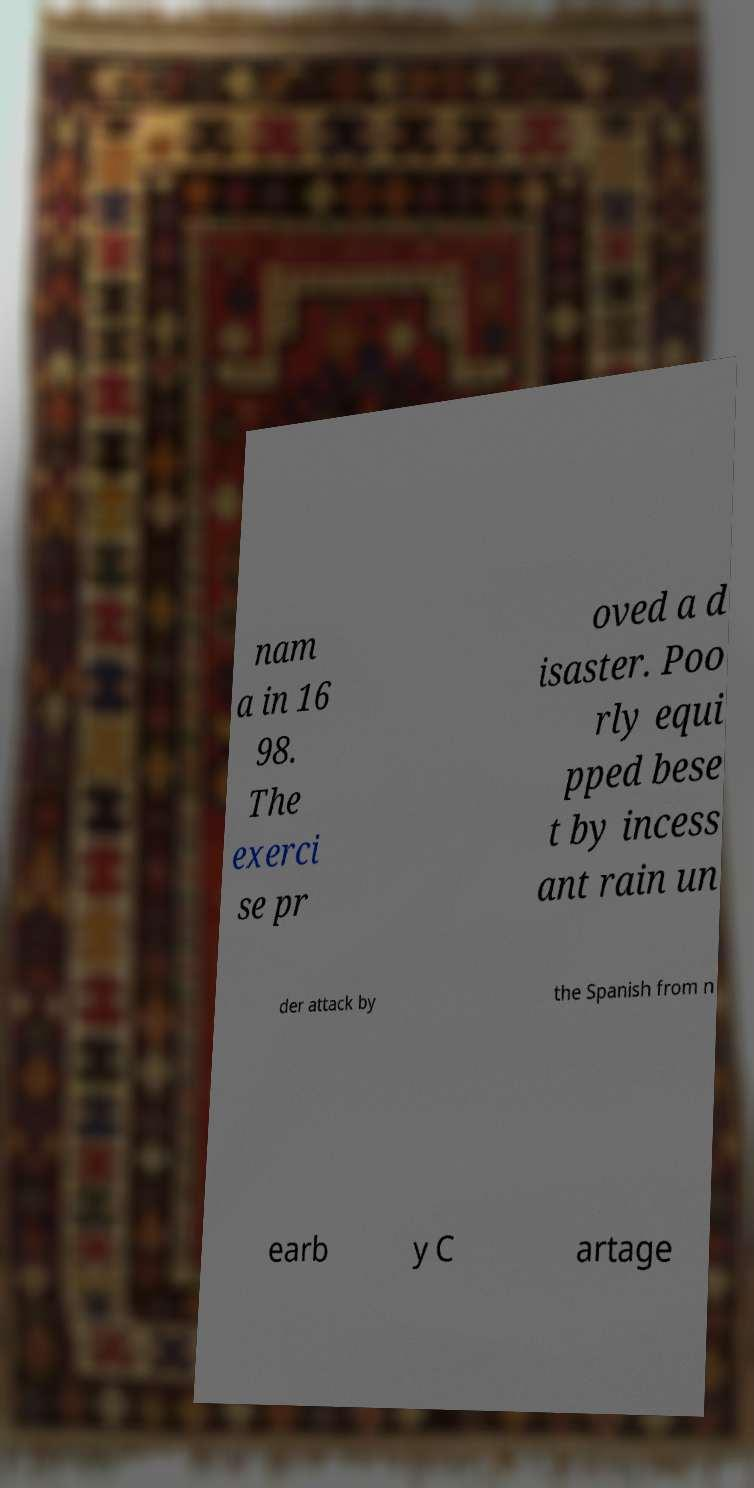I need the written content from this picture converted into text. Can you do that? nam a in 16 98. The exerci se pr oved a d isaster. Poo rly equi pped bese t by incess ant rain un der attack by the Spanish from n earb y C artage 